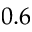<formula> <loc_0><loc_0><loc_500><loc_500>0 . 6</formula> 